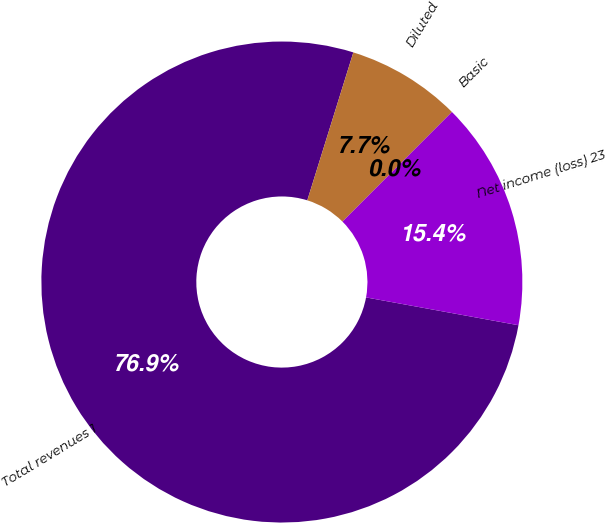<chart> <loc_0><loc_0><loc_500><loc_500><pie_chart><fcel>Total revenues 1<fcel>Net income (loss) 23<fcel>Basic<fcel>Diluted<nl><fcel>76.92%<fcel>15.38%<fcel>0.0%<fcel>7.69%<nl></chart> 